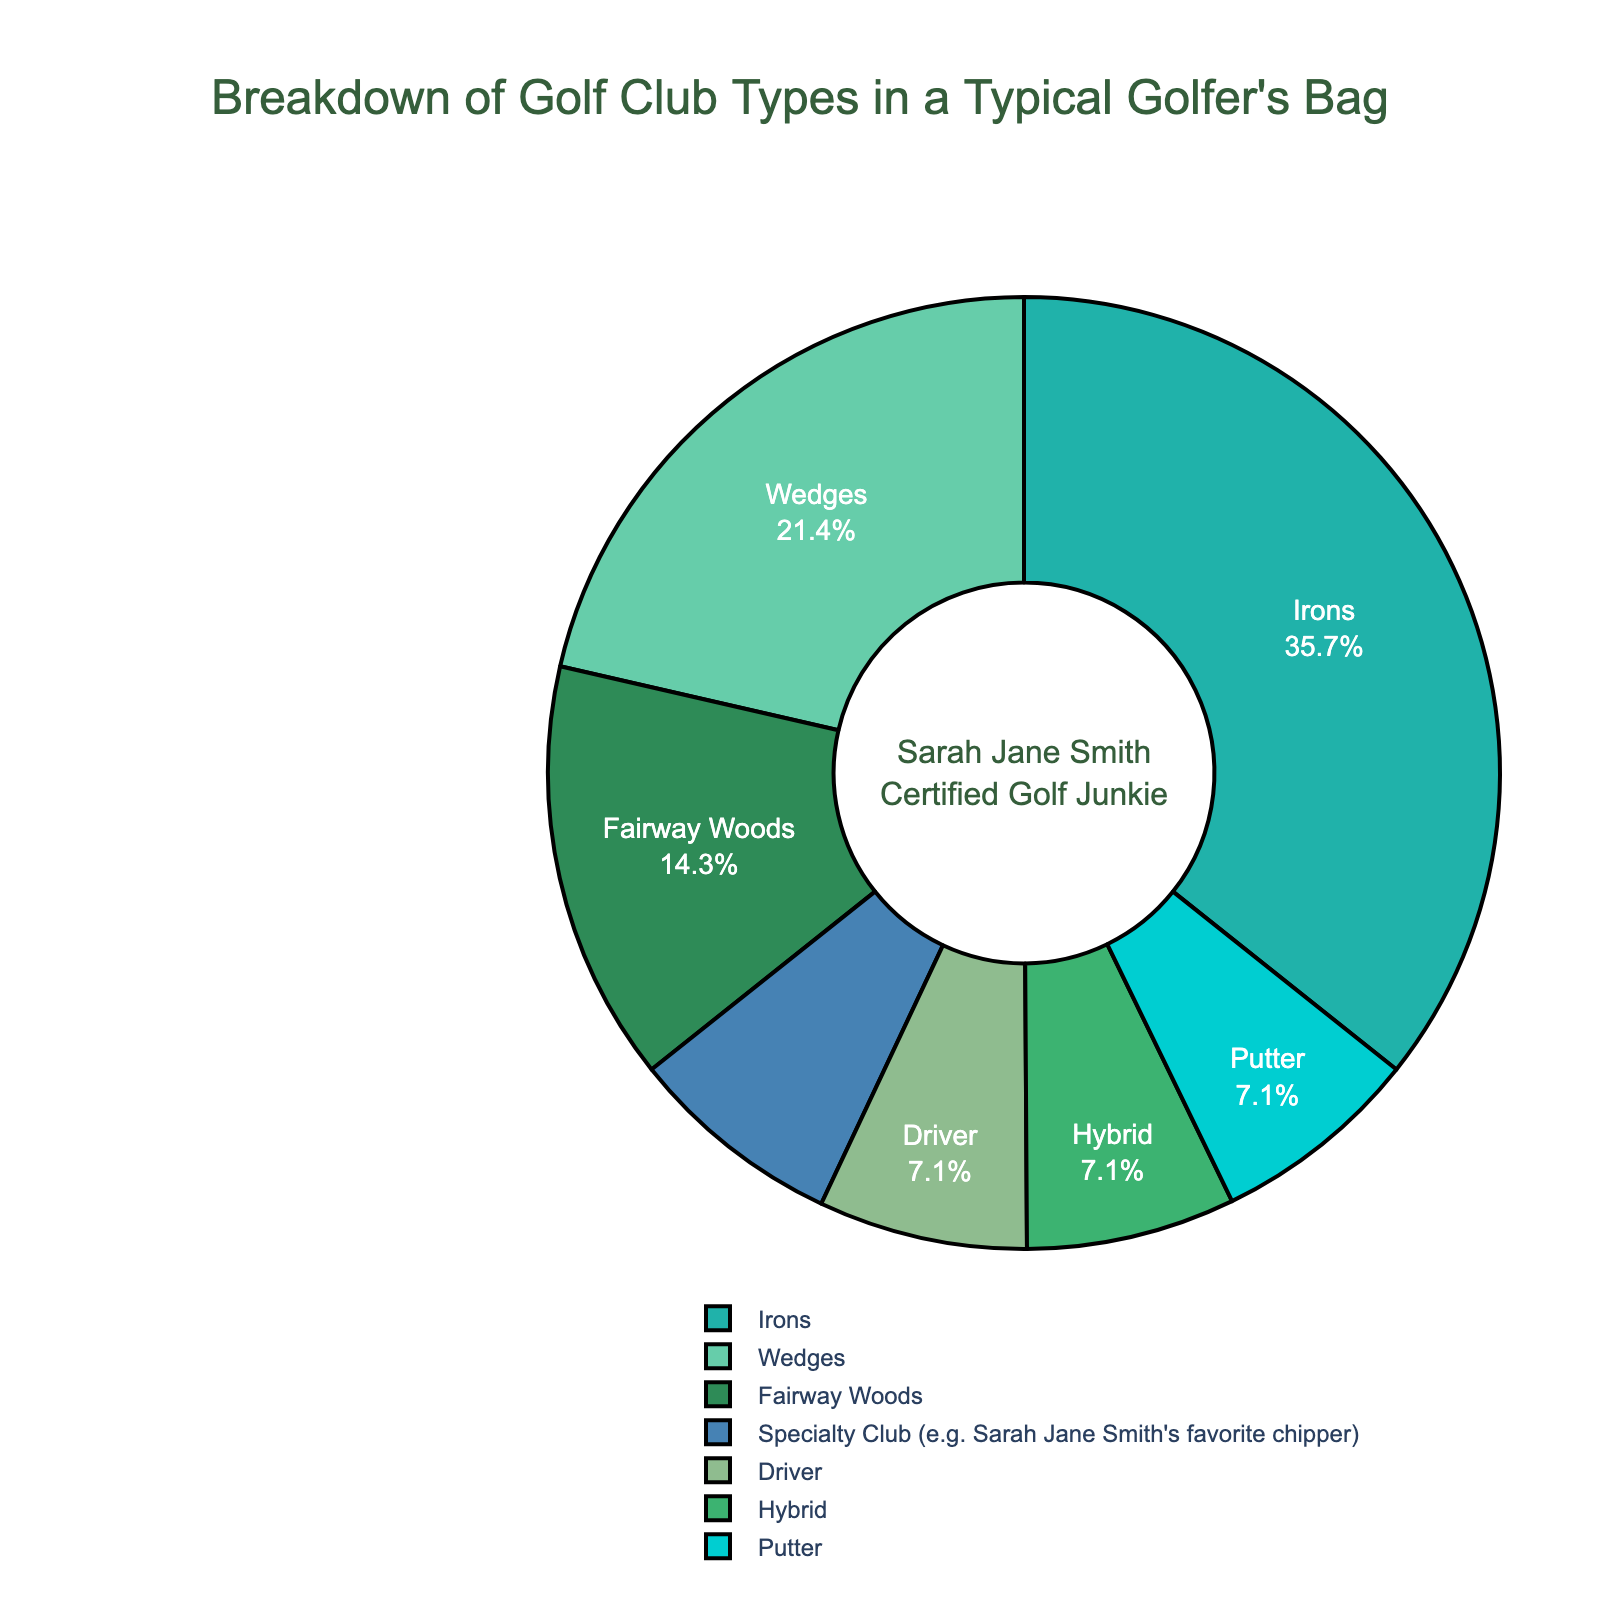Which type of golf club is the most common in a typical golfer's bag? The pie chart shows that Irons have the highest percentage.
Answer: Irons What percentage of the clubs in a typical golfer's bag are putters? Refer to the chart and locate the section marked "Putter," which shows 7.1%.
Answer: 7.1% How does the percentage of Wedges compare to that of Drivers? Wedges make up 21.4% while Drivers are only 7.1%, so Wedges are more common.
Answer: Wedges are more common What's the combined percentage of Fairway Woods and Hybrids? Fairway Woods are 14.3% and Hybrids are 7.1%, so the combined percentage is 14.3 + 7.1 = 21.4%.
Answer: 21.4% What type of specialty club, such as Sarah Jane Smith's favorite chipper, is included in the data? The chart lists "Specialty Club" with 7.3%.
Answer: Specialty Club Which golf club type occupies exactly the same percentage as putters in the chart? Both Drivers and Hybrids have the same percentage as Putters, which is 7.1%.
Answer: Drivers and Hybrids How much more common are Irons than Drivers? Irons make up 35.7% and Drivers 7.1%, so the difference is 35.7 - 7.1 = 28.6%.
Answer: 28.6% If you sum up the percentages of Wedges, Putters, and Hybrids, what do you get? Wedges are 21.4%, Putters 7.1%, and Hybrids 7.1%. Summing these gives 21.4 + 7.1 + 7.1 = 35.6%.
Answer: 35.6% What color is used to represent Fairway Woods on the pie chart? The Fairway Woods section is marked in a specific shade, which is green-like color from the palette used.
Answer: Green Are the percentages for all listed golf clubs equal or different? Review the data; each category has a distinct percentage.
Answer: Different 